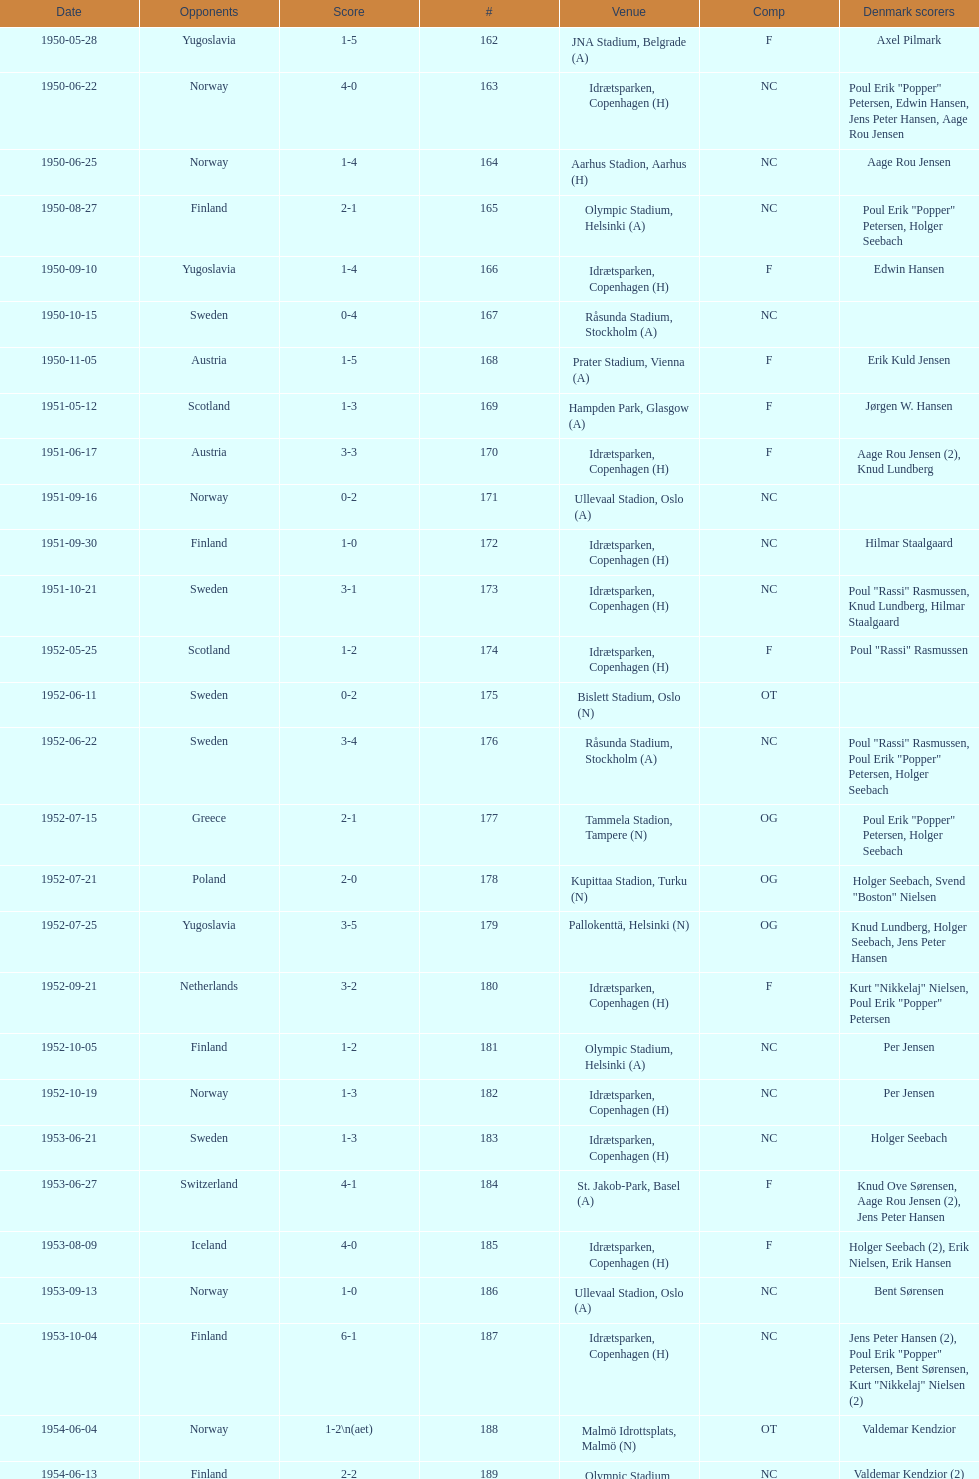Is denmark better against sweden or england? Sweden. 